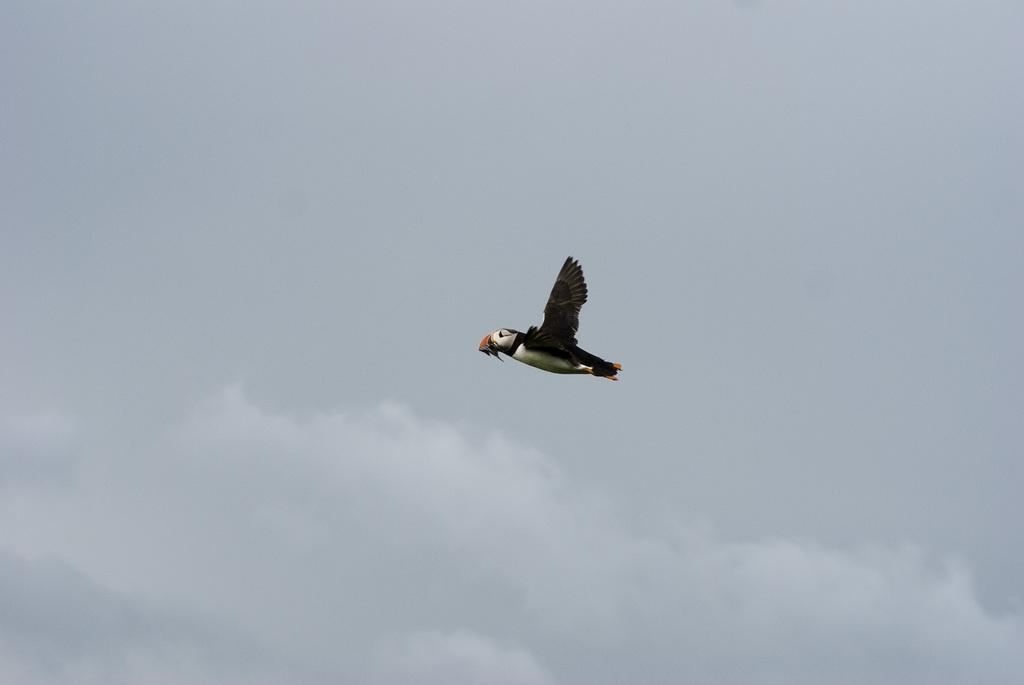What type of animal is present in the image? There is a bird in the image. Can you describe the color pattern of the bird? The bird is white and black in color. What can be seen in the background of the image? The sky is visible in the background of the image. What type of tub is visible in the image? There is no tub present in the image. Can you describe the bird's voice in the image? The image is a still image, so it does not capture any sounds, including the bird's voice. 